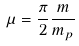<formula> <loc_0><loc_0><loc_500><loc_500>\mu = \frac { \pi } { 2 } \frac { m } { m _ { p } }</formula> 